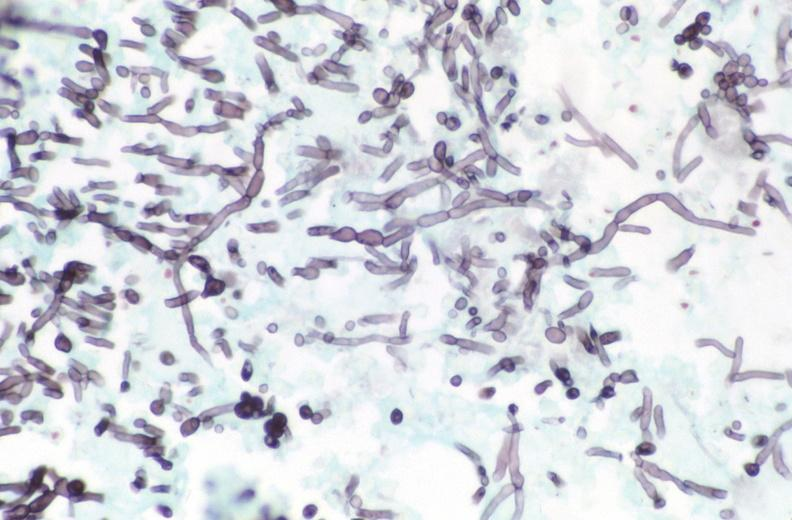do silver stain?
Answer the question using a single word or phrase. Yes 